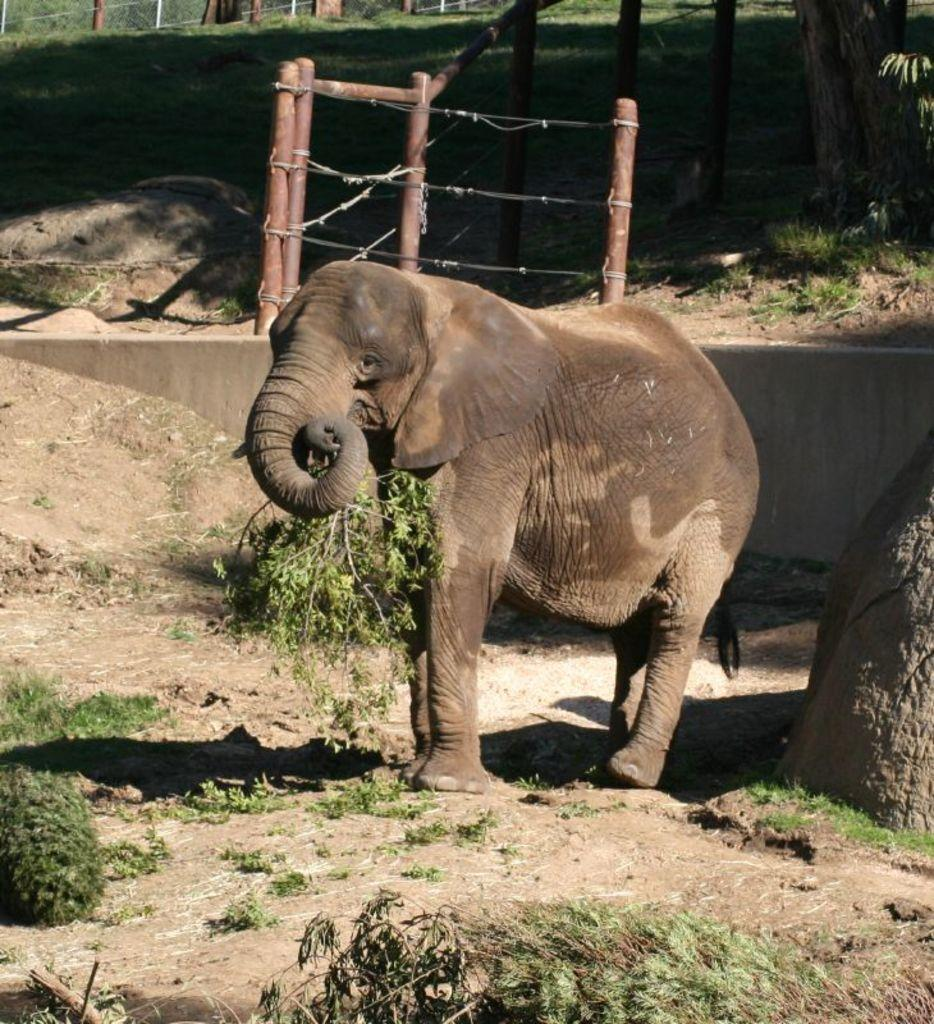What animal is present in the image? There is an elephant in the image. Where is the elephant located? The elephant is on the ground. What can be seen in the background of the image? There is a fence and grass in the background of the image. What type of argument is the elephant having with its dad in the image? There is no argument or dad present in the image; it features an elephant on the ground with a fence and grass in the background. 